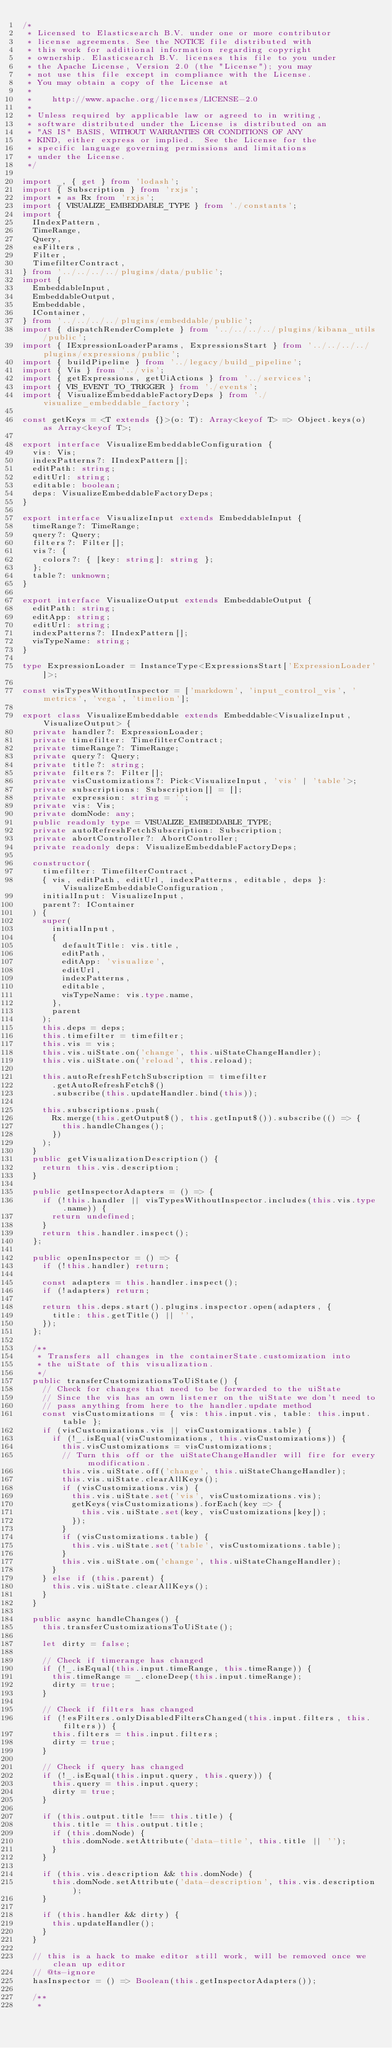Convert code to text. <code><loc_0><loc_0><loc_500><loc_500><_TypeScript_>/*
 * Licensed to Elasticsearch B.V. under one or more contributor
 * license agreements. See the NOTICE file distributed with
 * this work for additional information regarding copyright
 * ownership. Elasticsearch B.V. licenses this file to you under
 * the Apache License, Version 2.0 (the "License"); you may
 * not use this file except in compliance with the License.
 * You may obtain a copy of the License at
 *
 *    http://www.apache.org/licenses/LICENSE-2.0
 *
 * Unless required by applicable law or agreed to in writing,
 * software distributed under the License is distributed on an
 * "AS IS" BASIS, WITHOUT WARRANTIES OR CONDITIONS OF ANY
 * KIND, either express or implied.  See the License for the
 * specific language governing permissions and limitations
 * under the License.
 */

import _, { get } from 'lodash';
import { Subscription } from 'rxjs';
import * as Rx from 'rxjs';
import { VISUALIZE_EMBEDDABLE_TYPE } from './constants';
import {
  IIndexPattern,
  TimeRange,
  Query,
  esFilters,
  Filter,
  TimefilterContract,
} from '../../../../plugins/data/public';
import {
  EmbeddableInput,
  EmbeddableOutput,
  Embeddable,
  IContainer,
} from '../../../../plugins/embeddable/public';
import { dispatchRenderComplete } from '../../../../plugins/kibana_utils/public';
import { IExpressionLoaderParams, ExpressionsStart } from '../../../../plugins/expressions/public';
import { buildPipeline } from '../legacy/build_pipeline';
import { Vis } from '../vis';
import { getExpressions, getUiActions } from '../services';
import { VIS_EVENT_TO_TRIGGER } from './events';
import { VisualizeEmbeddableFactoryDeps } from './visualize_embeddable_factory';

const getKeys = <T extends {}>(o: T): Array<keyof T> => Object.keys(o) as Array<keyof T>;

export interface VisualizeEmbeddableConfiguration {
  vis: Vis;
  indexPatterns?: IIndexPattern[];
  editPath: string;
  editUrl: string;
  editable: boolean;
  deps: VisualizeEmbeddableFactoryDeps;
}

export interface VisualizeInput extends EmbeddableInput {
  timeRange?: TimeRange;
  query?: Query;
  filters?: Filter[];
  vis?: {
    colors?: { [key: string]: string };
  };
  table?: unknown;
}

export interface VisualizeOutput extends EmbeddableOutput {
  editPath: string;
  editApp: string;
  editUrl: string;
  indexPatterns?: IIndexPattern[];
  visTypeName: string;
}

type ExpressionLoader = InstanceType<ExpressionsStart['ExpressionLoader']>;

const visTypesWithoutInspector = ['markdown', 'input_control_vis', 'metrics', 'vega', 'timelion'];

export class VisualizeEmbeddable extends Embeddable<VisualizeInput, VisualizeOutput> {
  private handler?: ExpressionLoader;
  private timefilter: TimefilterContract;
  private timeRange?: TimeRange;
  private query?: Query;
  private title?: string;
  private filters?: Filter[];
  private visCustomizations?: Pick<VisualizeInput, 'vis' | 'table'>;
  private subscriptions: Subscription[] = [];
  private expression: string = '';
  private vis: Vis;
  private domNode: any;
  public readonly type = VISUALIZE_EMBEDDABLE_TYPE;
  private autoRefreshFetchSubscription: Subscription;
  private abortController?: AbortController;
  private readonly deps: VisualizeEmbeddableFactoryDeps;

  constructor(
    timefilter: TimefilterContract,
    { vis, editPath, editUrl, indexPatterns, editable, deps }: VisualizeEmbeddableConfiguration,
    initialInput: VisualizeInput,
    parent?: IContainer
  ) {
    super(
      initialInput,
      {
        defaultTitle: vis.title,
        editPath,
        editApp: 'visualize',
        editUrl,
        indexPatterns,
        editable,
        visTypeName: vis.type.name,
      },
      parent
    );
    this.deps = deps;
    this.timefilter = timefilter;
    this.vis = vis;
    this.vis.uiState.on('change', this.uiStateChangeHandler);
    this.vis.uiState.on('reload', this.reload);

    this.autoRefreshFetchSubscription = timefilter
      .getAutoRefreshFetch$()
      .subscribe(this.updateHandler.bind(this));

    this.subscriptions.push(
      Rx.merge(this.getOutput$(), this.getInput$()).subscribe(() => {
        this.handleChanges();
      })
    );
  }
  public getVisualizationDescription() {
    return this.vis.description;
  }

  public getInspectorAdapters = () => {
    if (!this.handler || visTypesWithoutInspector.includes(this.vis.type.name)) {
      return undefined;
    }
    return this.handler.inspect();
  };

  public openInspector = () => {
    if (!this.handler) return;

    const adapters = this.handler.inspect();
    if (!adapters) return;

    return this.deps.start().plugins.inspector.open(adapters, {
      title: this.getTitle() || '',
    });
  };

  /**
   * Transfers all changes in the containerState.customization into
   * the uiState of this visualization.
   */
  public transferCustomizationsToUiState() {
    // Check for changes that need to be forwarded to the uiState
    // Since the vis has an own listener on the uiState we don't need to
    // pass anything from here to the handler.update method
    const visCustomizations = { vis: this.input.vis, table: this.input.table };
    if (visCustomizations.vis || visCustomizations.table) {
      if (!_.isEqual(visCustomizations, this.visCustomizations)) {
        this.visCustomizations = visCustomizations;
        // Turn this off or the uiStateChangeHandler will fire for every modification.
        this.vis.uiState.off('change', this.uiStateChangeHandler);
        this.vis.uiState.clearAllKeys();
        if (visCustomizations.vis) {
          this.vis.uiState.set('vis', visCustomizations.vis);
          getKeys(visCustomizations).forEach(key => {
            this.vis.uiState.set(key, visCustomizations[key]);
          });
        }
        if (visCustomizations.table) {
          this.vis.uiState.set('table', visCustomizations.table);
        }
        this.vis.uiState.on('change', this.uiStateChangeHandler);
      }
    } else if (this.parent) {
      this.vis.uiState.clearAllKeys();
    }
  }

  public async handleChanges() {
    this.transferCustomizationsToUiState();

    let dirty = false;

    // Check if timerange has changed
    if (!_.isEqual(this.input.timeRange, this.timeRange)) {
      this.timeRange = _.cloneDeep(this.input.timeRange);
      dirty = true;
    }

    // Check if filters has changed
    if (!esFilters.onlyDisabledFiltersChanged(this.input.filters, this.filters)) {
      this.filters = this.input.filters;
      dirty = true;
    }

    // Check if query has changed
    if (!_.isEqual(this.input.query, this.query)) {
      this.query = this.input.query;
      dirty = true;
    }

    if (this.output.title !== this.title) {
      this.title = this.output.title;
      if (this.domNode) {
        this.domNode.setAttribute('data-title', this.title || '');
      }
    }

    if (this.vis.description && this.domNode) {
      this.domNode.setAttribute('data-description', this.vis.description);
    }

    if (this.handler && dirty) {
      this.updateHandler();
    }
  }

  // this is a hack to make editor still work, will be removed once we clean up editor
  // @ts-ignore
  hasInspector = () => Boolean(this.getInspectorAdapters());

  /**
   *</code> 